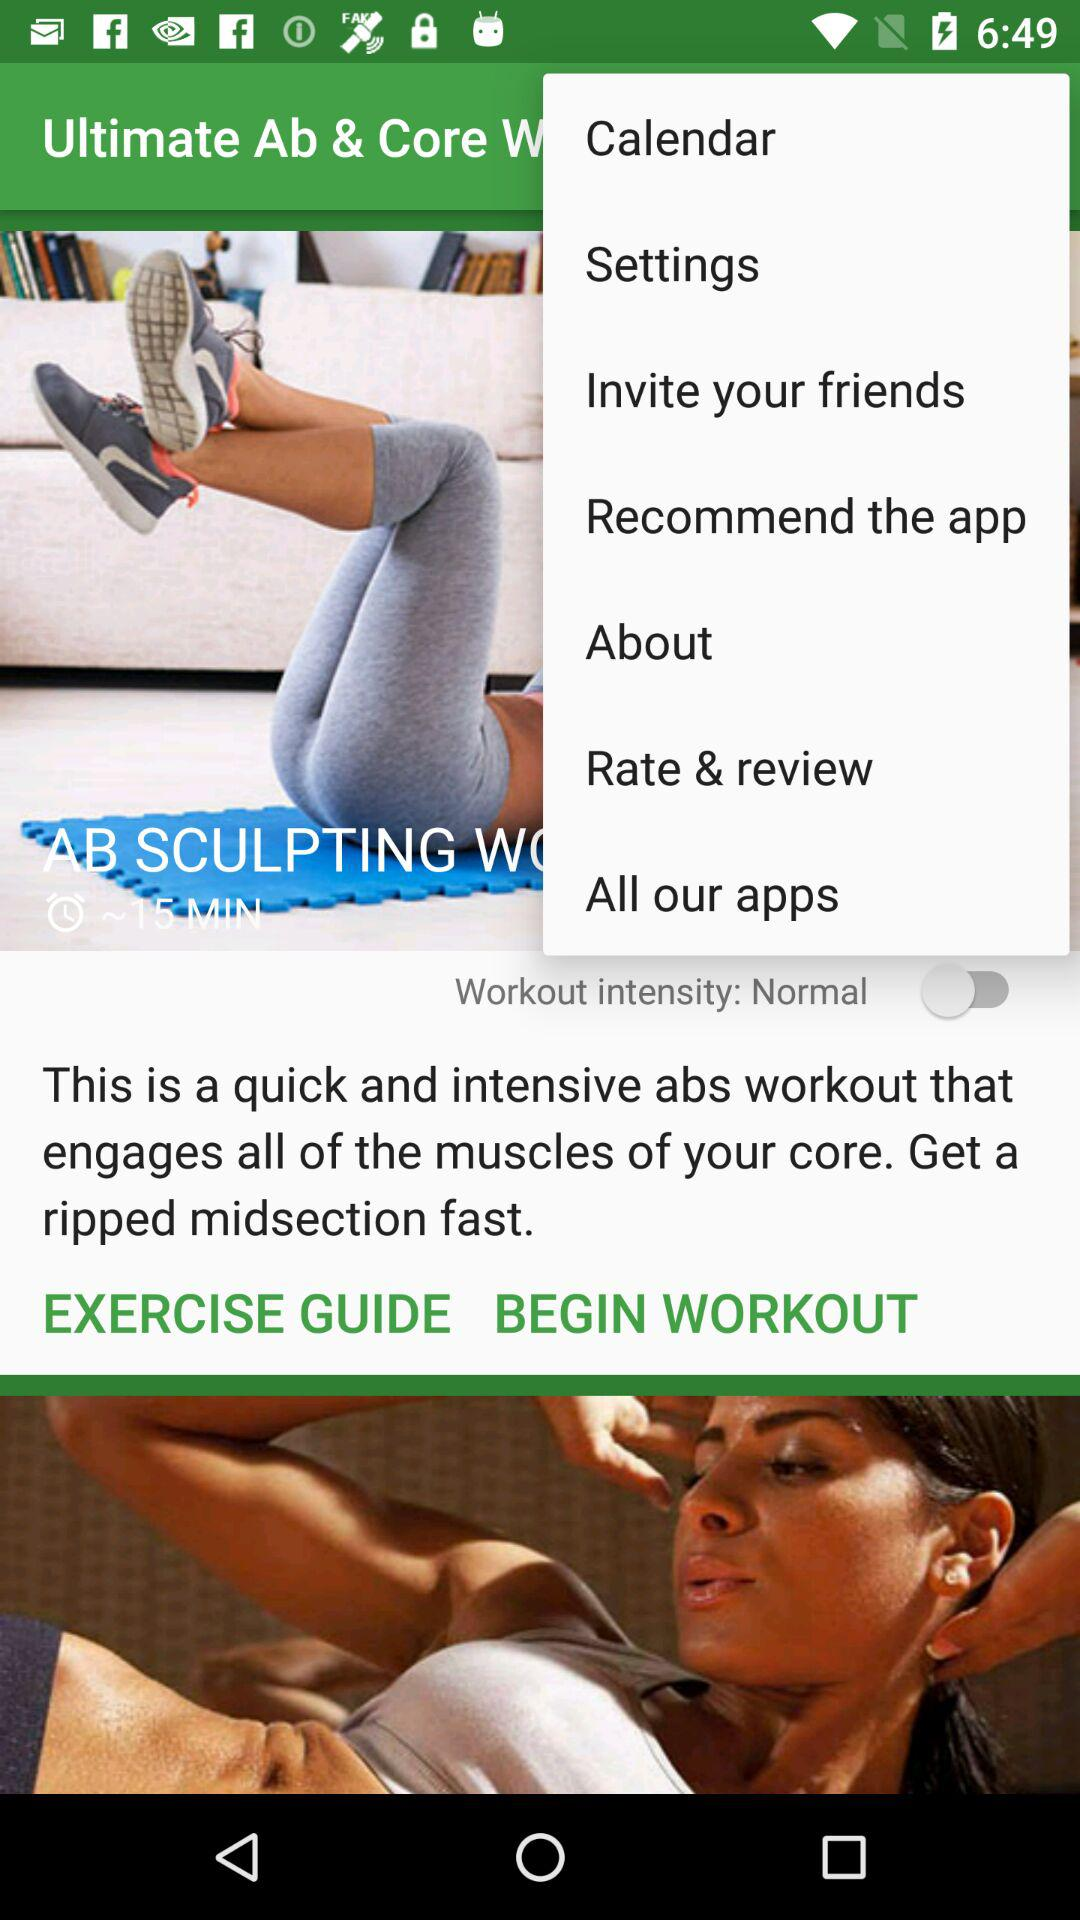What is the workout intensity? The workout intensity is normal. 